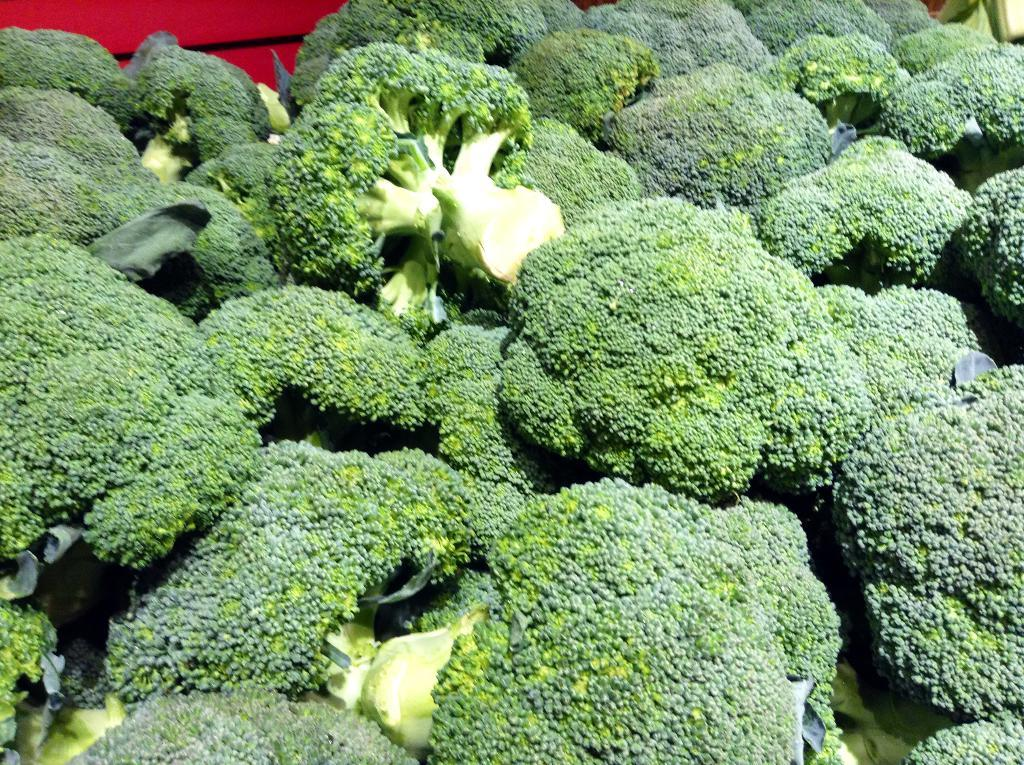What type of vegetable is present in the image? There are broccoli in the image. Can you describe the appearance of the broccoli? The broccoli appears to be green and has a tree-like structure with small florets. How many broccoli can be seen in the image? The number of broccoli visible in the image is not specified, but there is at least one broccoli present. What type of stamp can be seen on the broccoli in the image? There is no stamp present on the broccoli in the image. 